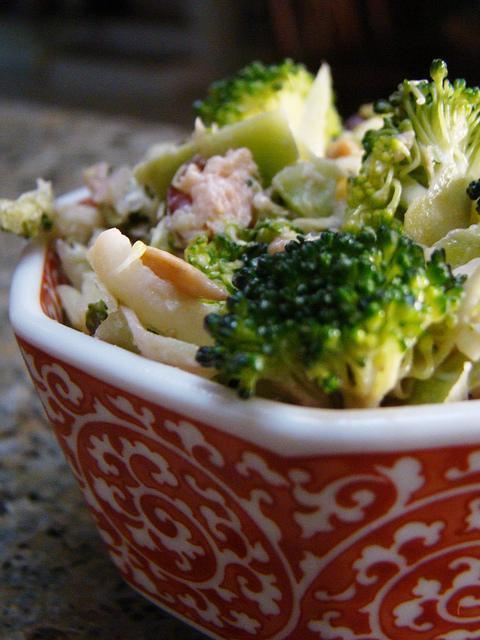How many broccolis are there?
Give a very brief answer. 4. 